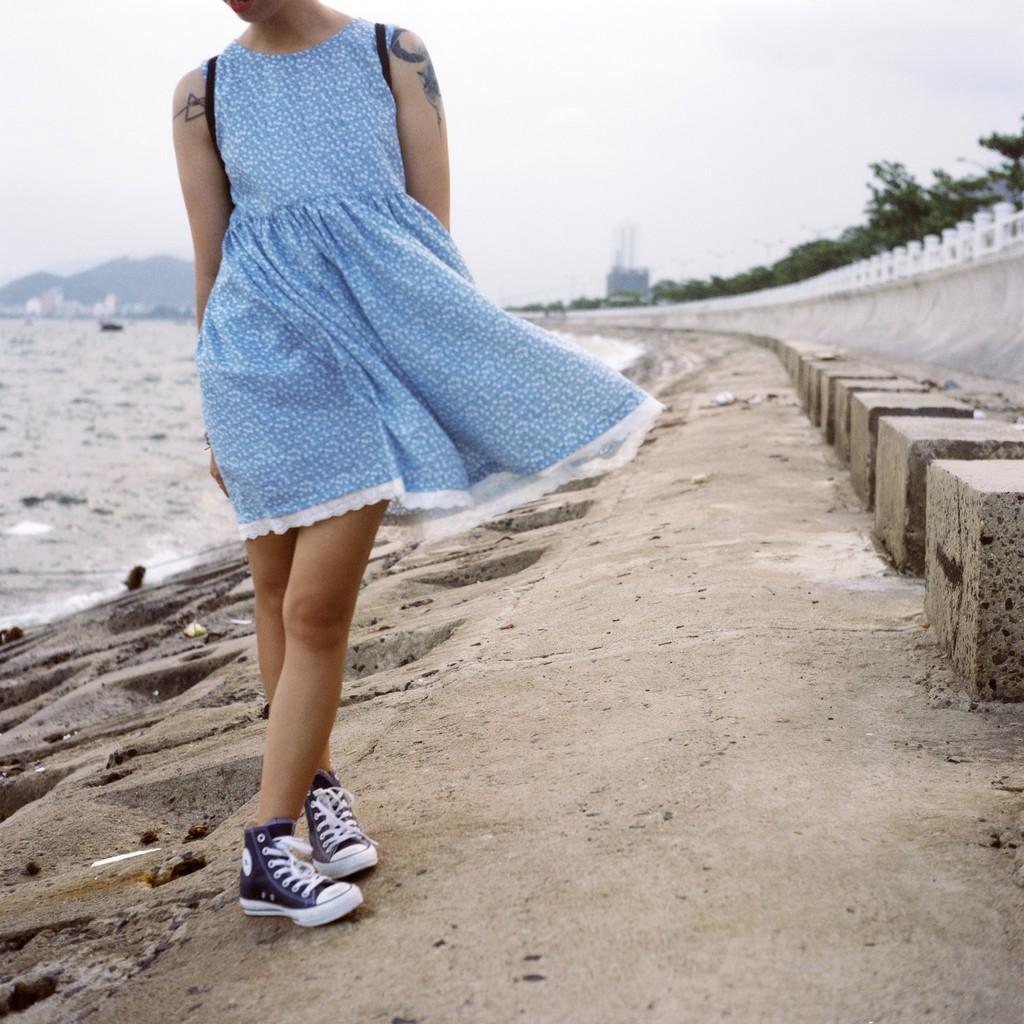In one or two sentences, can you explain what this image depicts? In the foreground of the image there is a person. In the background of the image there is water, mountain, trees, sky. At the bottom of the image there is floor. 